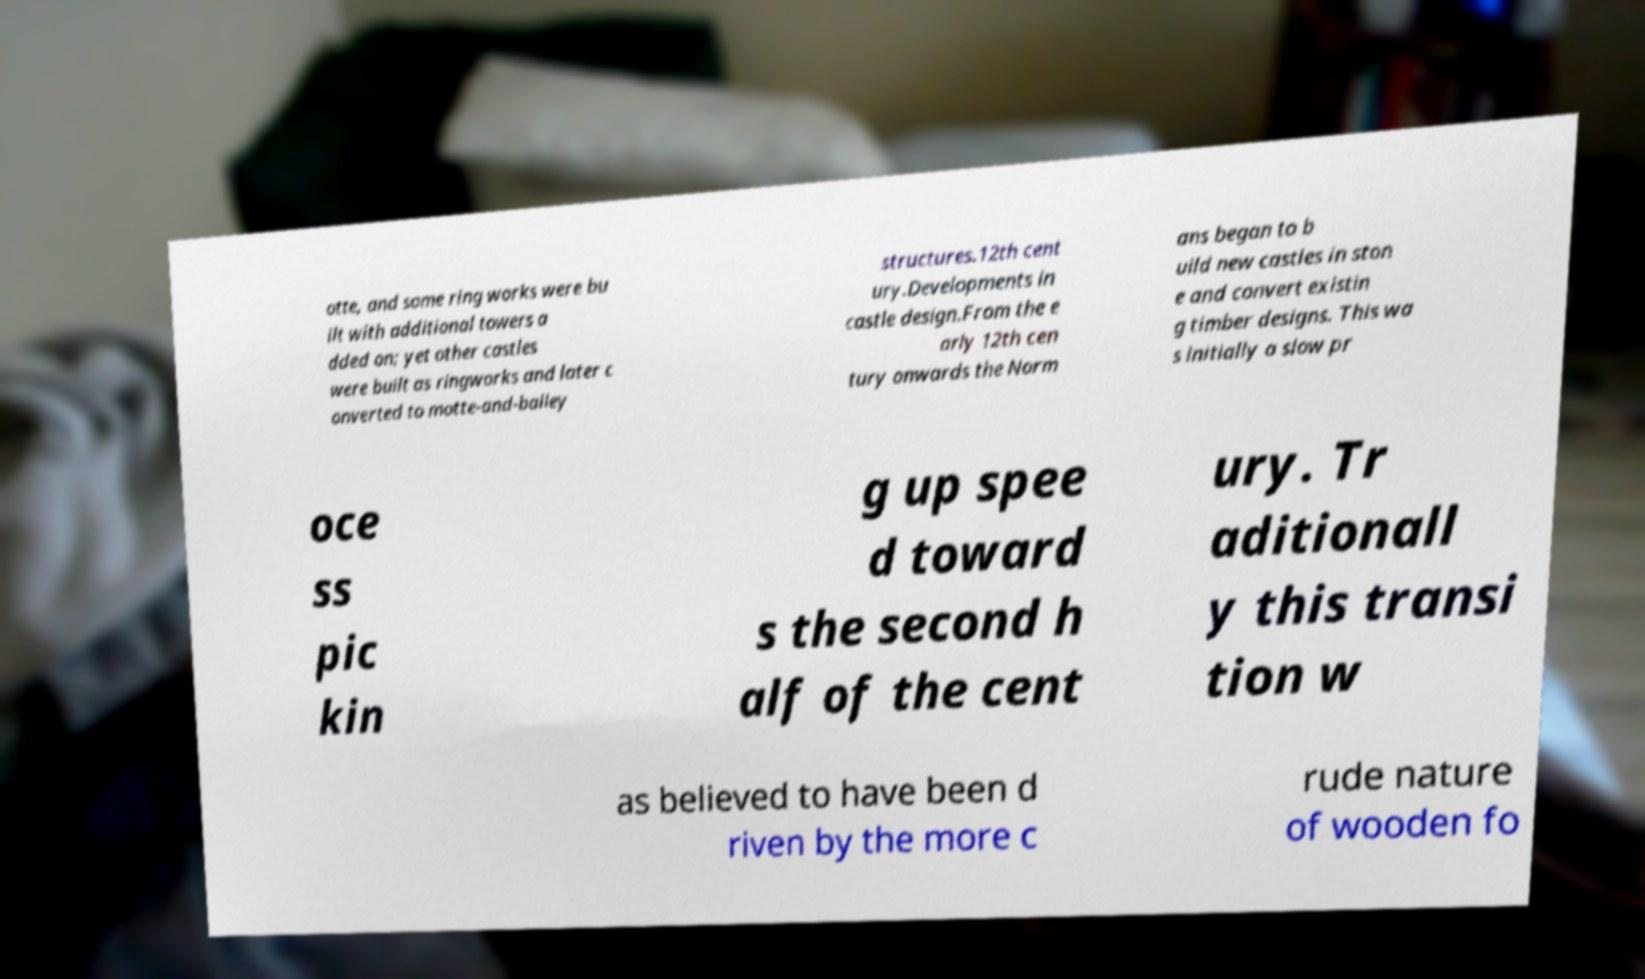Can you read and provide the text displayed in the image?This photo seems to have some interesting text. Can you extract and type it out for me? otte, and some ring works were bu ilt with additional towers a dded on; yet other castles were built as ringworks and later c onverted to motte-and-bailey structures.12th cent ury.Developments in castle design.From the e arly 12th cen tury onwards the Norm ans began to b uild new castles in ston e and convert existin g timber designs. This wa s initially a slow pr oce ss pic kin g up spee d toward s the second h alf of the cent ury. Tr aditionall y this transi tion w as believed to have been d riven by the more c rude nature of wooden fo 